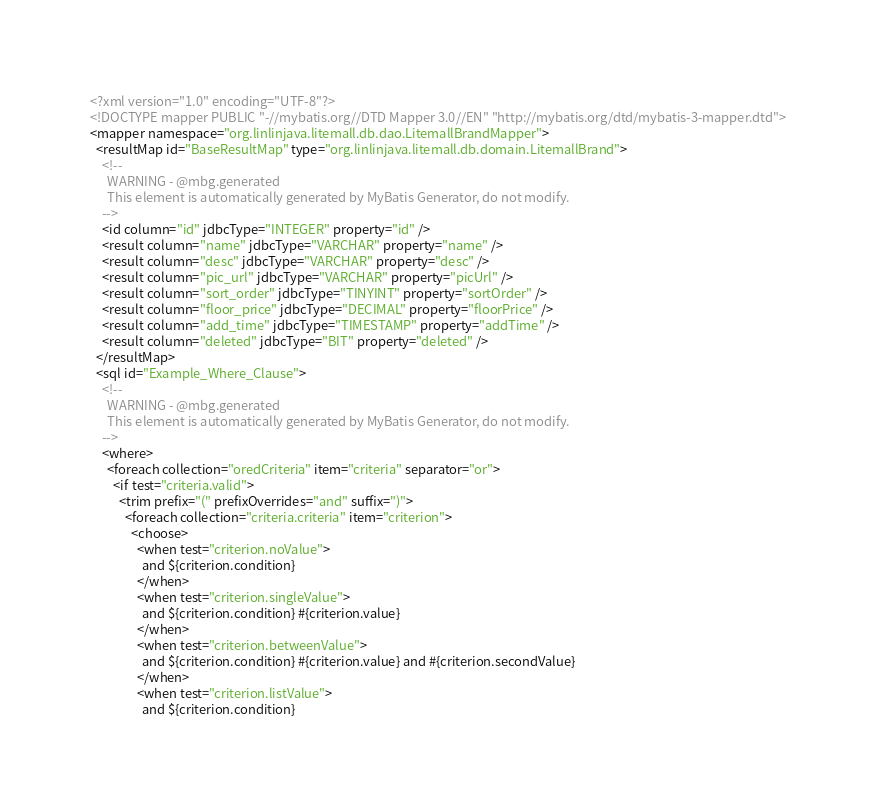<code> <loc_0><loc_0><loc_500><loc_500><_XML_><?xml version="1.0" encoding="UTF-8"?>
<!DOCTYPE mapper PUBLIC "-//mybatis.org//DTD Mapper 3.0//EN" "http://mybatis.org/dtd/mybatis-3-mapper.dtd">
<mapper namespace="org.linlinjava.litemall.db.dao.LitemallBrandMapper">
  <resultMap id="BaseResultMap" type="org.linlinjava.litemall.db.domain.LitemallBrand">
    <!--
      WARNING - @mbg.generated
      This element is automatically generated by MyBatis Generator, do not modify.
    -->
    <id column="id" jdbcType="INTEGER" property="id" />
    <result column="name" jdbcType="VARCHAR" property="name" />
    <result column="desc" jdbcType="VARCHAR" property="desc" />
    <result column="pic_url" jdbcType="VARCHAR" property="picUrl" />
    <result column="sort_order" jdbcType="TINYINT" property="sortOrder" />
    <result column="floor_price" jdbcType="DECIMAL" property="floorPrice" />
    <result column="add_time" jdbcType="TIMESTAMP" property="addTime" />
    <result column="deleted" jdbcType="BIT" property="deleted" />
  </resultMap>
  <sql id="Example_Where_Clause">
    <!--
      WARNING - @mbg.generated
      This element is automatically generated by MyBatis Generator, do not modify.
    -->
    <where>
      <foreach collection="oredCriteria" item="criteria" separator="or">
        <if test="criteria.valid">
          <trim prefix="(" prefixOverrides="and" suffix=")">
            <foreach collection="criteria.criteria" item="criterion">
              <choose>
                <when test="criterion.noValue">
                  and ${criterion.condition}
                </when>
                <when test="criterion.singleValue">
                  and ${criterion.condition} #{criterion.value}
                </when>
                <when test="criterion.betweenValue">
                  and ${criterion.condition} #{criterion.value} and #{criterion.secondValue}
                </when>
                <when test="criterion.listValue">
                  and ${criterion.condition}</code> 